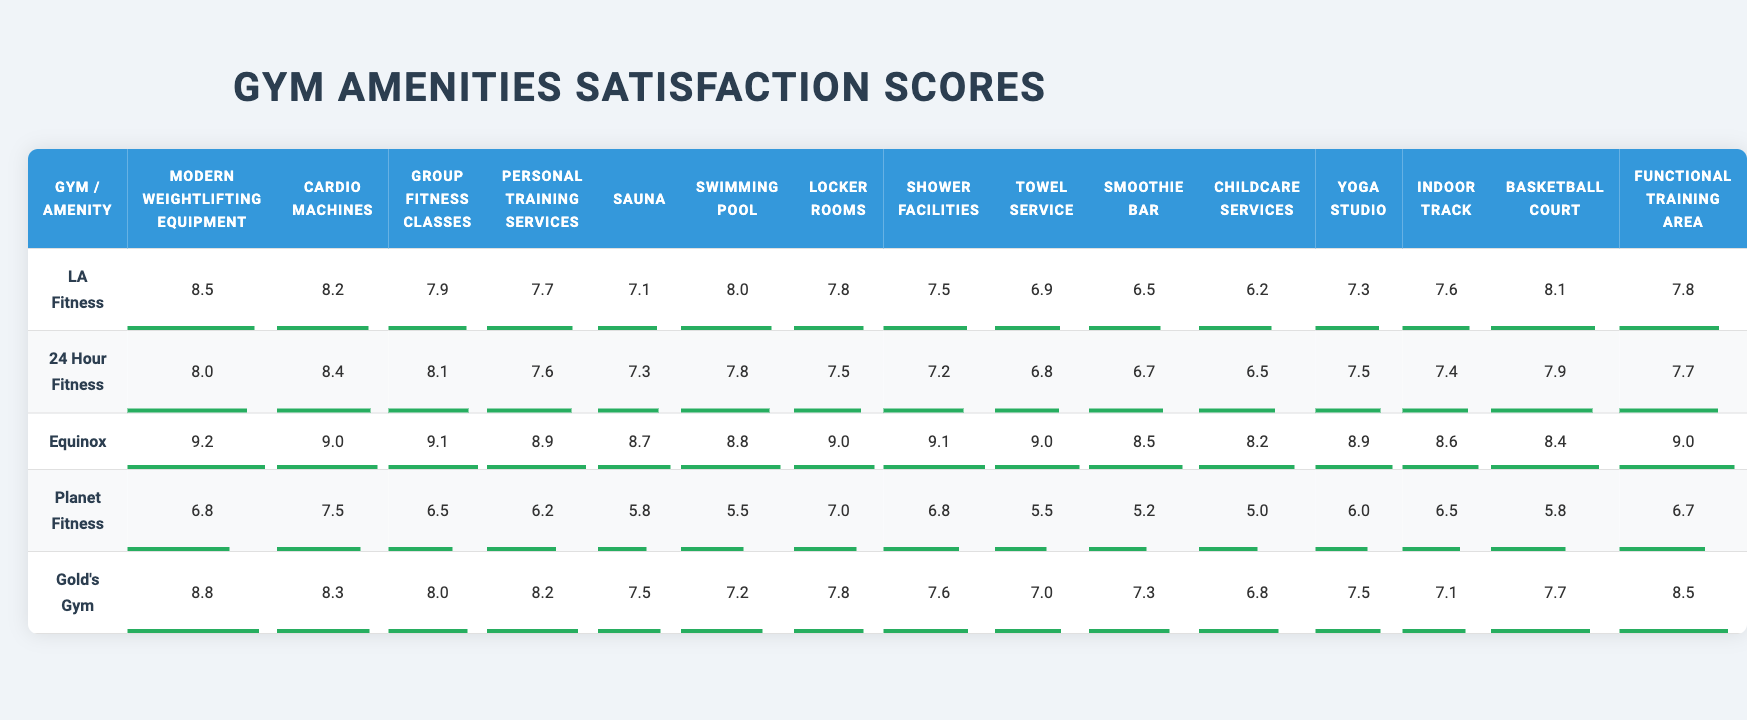What is the satisfaction score for cardio machines at Equinox? In the table, I find the row for Equinox and look under the column for cardio machines, which shows a score of 9.0.
Answer: 9.0 Which gym has the highest satisfaction score for modern weightlifting equipment? I review the scores for modern weightlifting equipment across all gyms, comparing the scores. Equinox has the highest score at 9.2.
Answer: Equinox Is the satisfaction score for group fitness classes at Gold's Gym greater than 7? I check the group fitness class score at Gold's Gym, which is 8.0, confirming that it is indeed greater than 7.
Answer: Yes What is the average satisfaction score for locker rooms across all gyms? I add the locker room scores: (7.8 + 7.5 + 9.0 + 7.0 + 7.8 + ...) and divide by the number of gyms (10), which gives an average of 7.57.
Answer: 7.57 Does any gym score below 6 for the sauna? I scan the sauna scores for each gym to look for any scores below 6. Planet Fitness has a score of 5.8, which is below 6.
Answer: Yes What are the top three gyms with the highest satisfaction scores for swimming pools? I list the swimming pool scores for each gym: LA Fitness (8.0), Equinox (8.8), and Gold's Gym (7.2). Sorting these, Equinox has the highest, followed by LA Fitness, then Gold's Gym.
Answer: Equinox, LA Fitness, Gold's Gym What is the difference in satisfaction scores for personal training services between 24 Hour Fitness and Planet Fitness? I find the personal training service scores: 24 Hour Fitness has 7.6 and Planet Fitness has 6.2. The difference is 7.6 - 6.2 = 1.4.
Answer: 1.4 Which gym provides the lowest satisfaction score for the smoothie bar? Upon checking the smoothie bar scores, Planet Fitness scores the lowest at 5.2.
Answer: Planet Fitness What is the total satisfaction score for all amenities at LA Fitness? I sum up all the scores for LA Fitness: 8.5 + 8.2 + 7.9 + 7.7 + 7.1 + 8.0 + 7.8 + 7.5 + 6.9 + 6.5 + 6.2 + 7.3 + 7.6 + 8.1 + 7.8, which equals 115.5.
Answer: 115.5 Is there any gym that has a average score above 8 across all amenities? I calculate the average scores for each gym by summing their scores and dividing by the number of amenities (15). Only Equinox achieves an average score above 8, which is 8.53.
Answer: Yes 